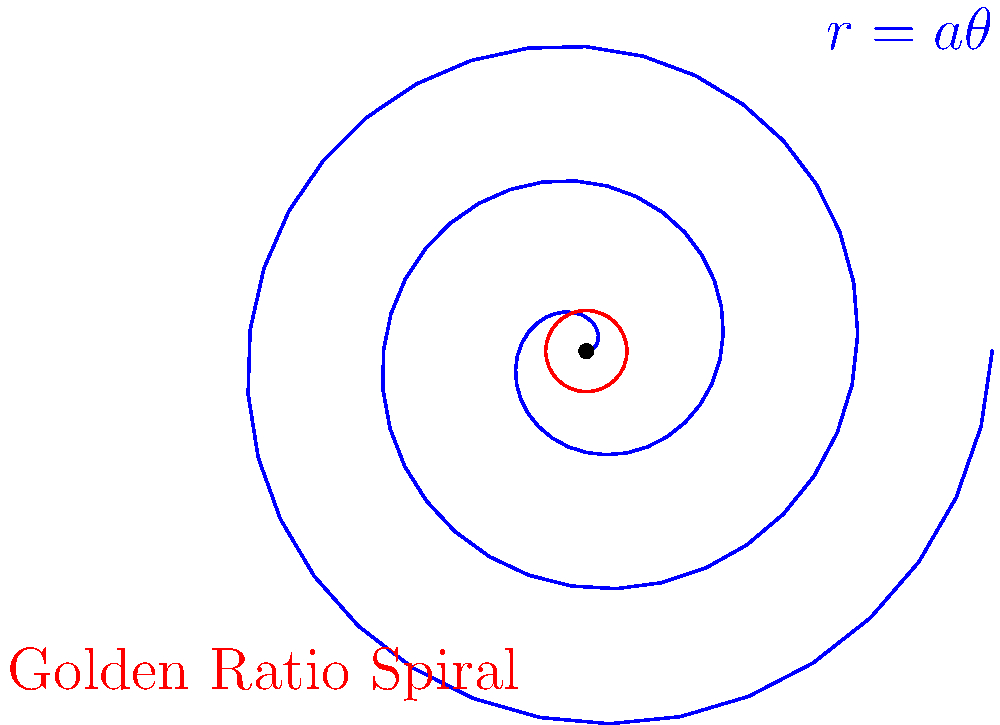In the context of cultural artifacts, the spiral of Archimedes (blue) is often compared to another significant spiral. Which famous mathematical concept, often found in art and architecture, does the red circle in this diagram represent in relation to spiral patterns? To answer this question, let's break down the key elements:

1. The blue spiral represents the spiral of Archimedes, defined by the equation $r = a\theta$ in polar coordinates, where $a$ is a constant.

2. The red circle in the diagram is not actually a circle, but a rough approximation of another type of spiral.

3. In cultural and artistic contexts, the most famous spiral pattern besides the Archimedean spiral is the Golden Spiral.

4. The Golden Spiral is based on the Golden Ratio, $\phi \approx 1.618$, which has been used in art, architecture, and design for centuries due to its aesthetic appeal.

5. Unlike the Archimedean spiral, which maintains a constant distance between turnings, the Golden Spiral grows exponentially, with each turn being approximately 1.618 times wider than the previous one.

6. The red "circle" in the diagram is actually an approximation of the Golden Spiral, drawn to contrast with the Archimedean spiral.

7. Both spirals have cultural significance:
   - The Archimedean spiral is often found in nature (e.g., snail shells) and has been used in ancient art and architecture.
   - The Golden Spiral, derived from the Golden Ratio, has been used in Renaissance art, modern architecture, and even in the design of everyday objects.

Therefore, the red circle in the diagram represents an approximation of the Golden Spiral, which is closely related to the Golden Ratio.
Answer: Golden Ratio 